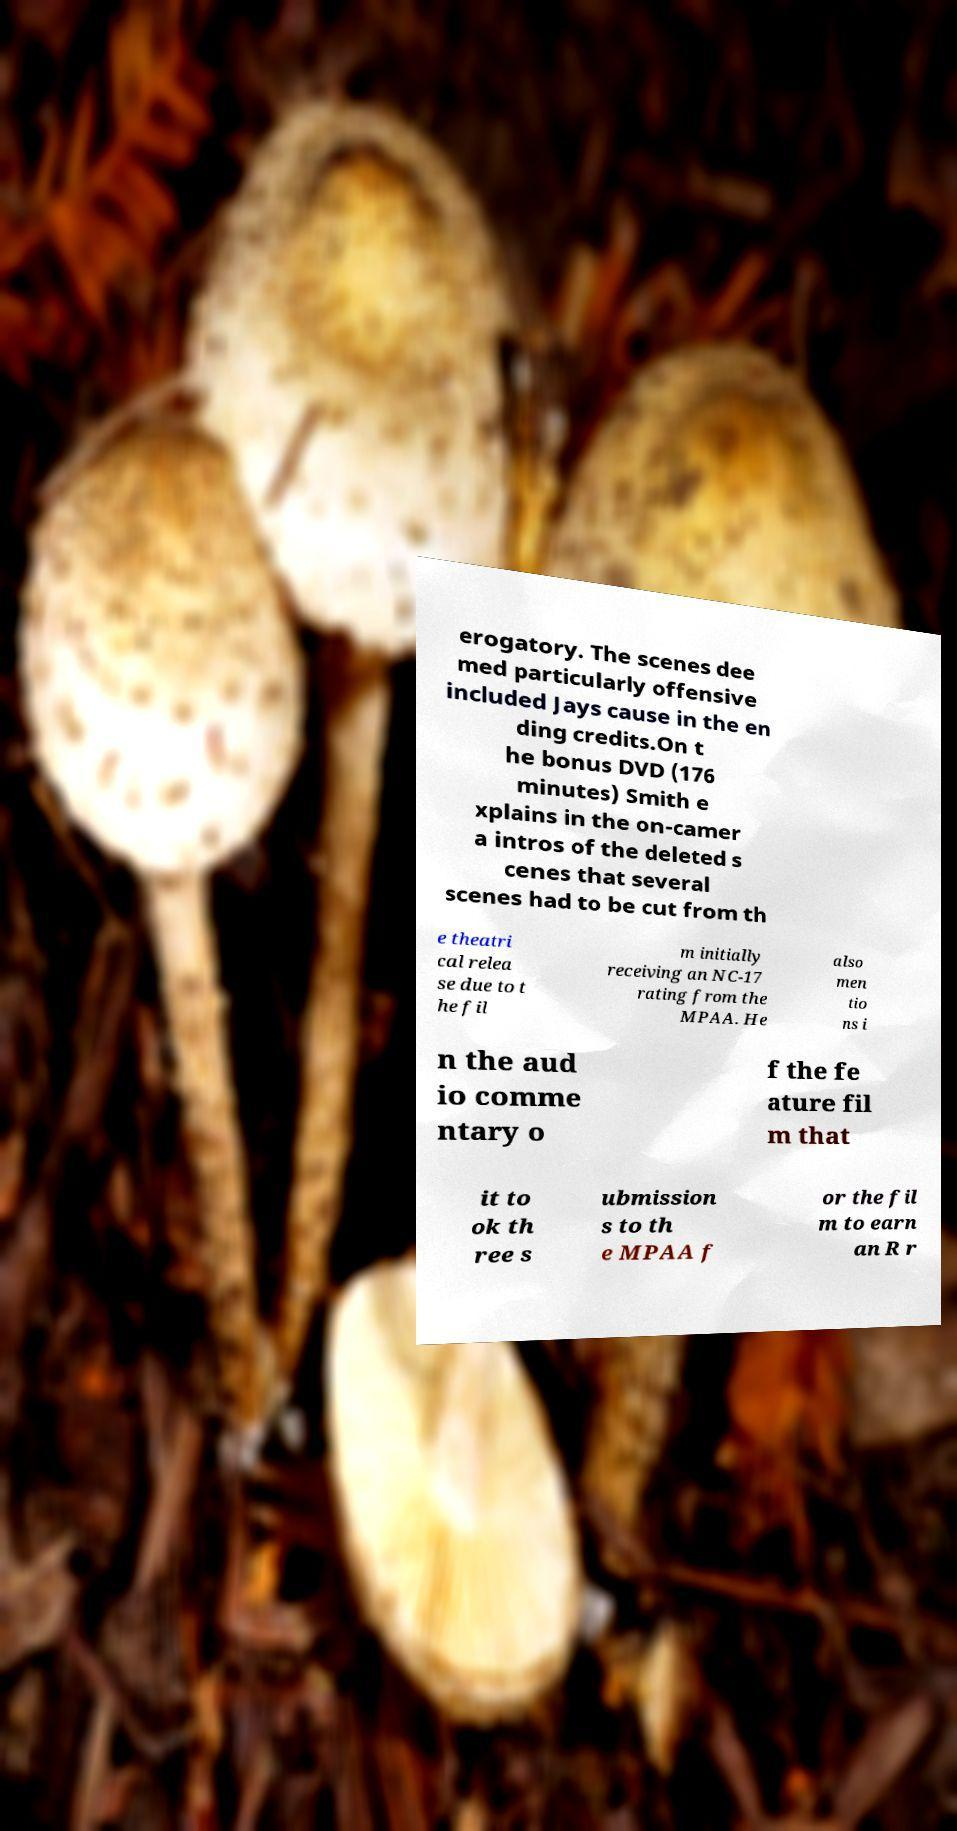I need the written content from this picture converted into text. Can you do that? erogatory. The scenes dee med particularly offensive included Jays cause in the en ding credits.On t he bonus DVD (176 minutes) Smith e xplains in the on-camer a intros of the deleted s cenes that several scenes had to be cut from th e theatri cal relea se due to t he fil m initially receiving an NC-17 rating from the MPAA. He also men tio ns i n the aud io comme ntary o f the fe ature fil m that it to ok th ree s ubmission s to th e MPAA f or the fil m to earn an R r 